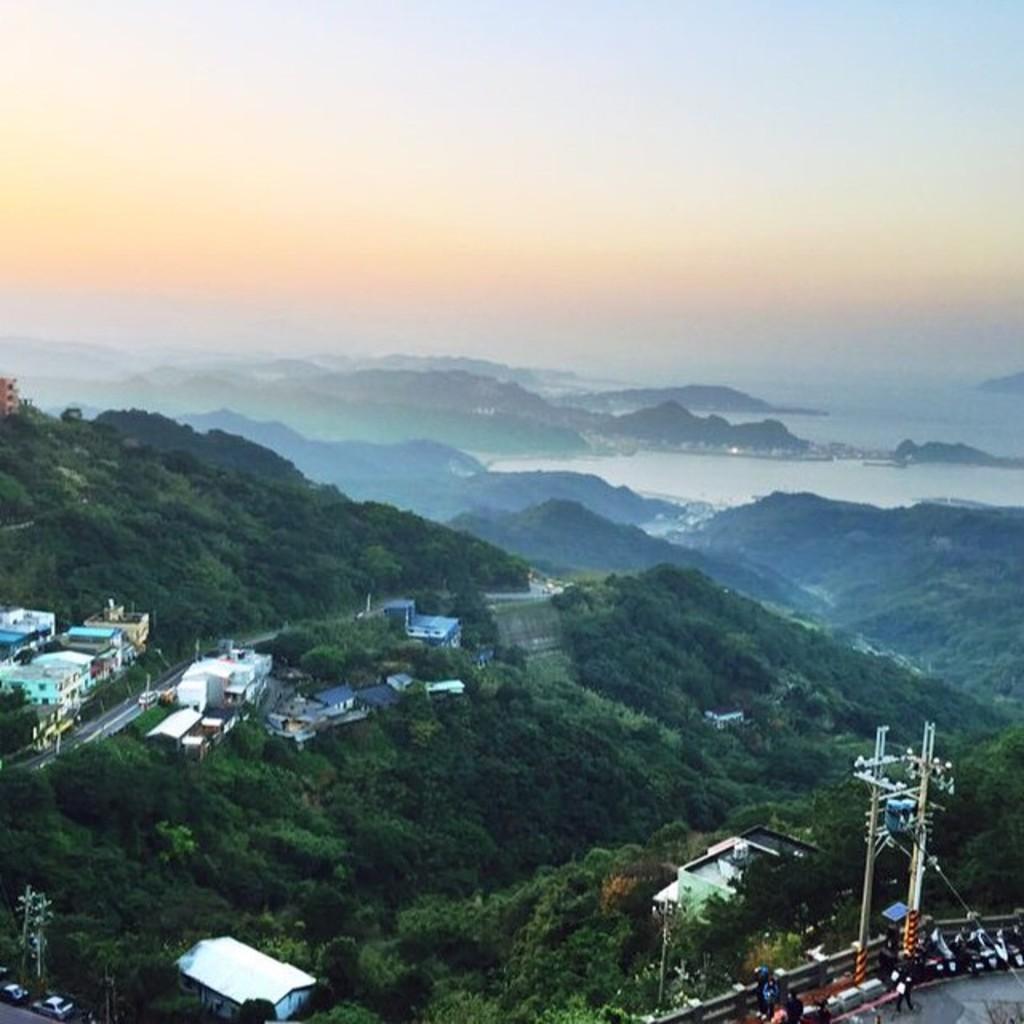Could you give a brief overview of what you see in this image? In this picture we can see buildings, vehicles on the road, trees, wall and some objects, mountains and in the background we can see the sky. 